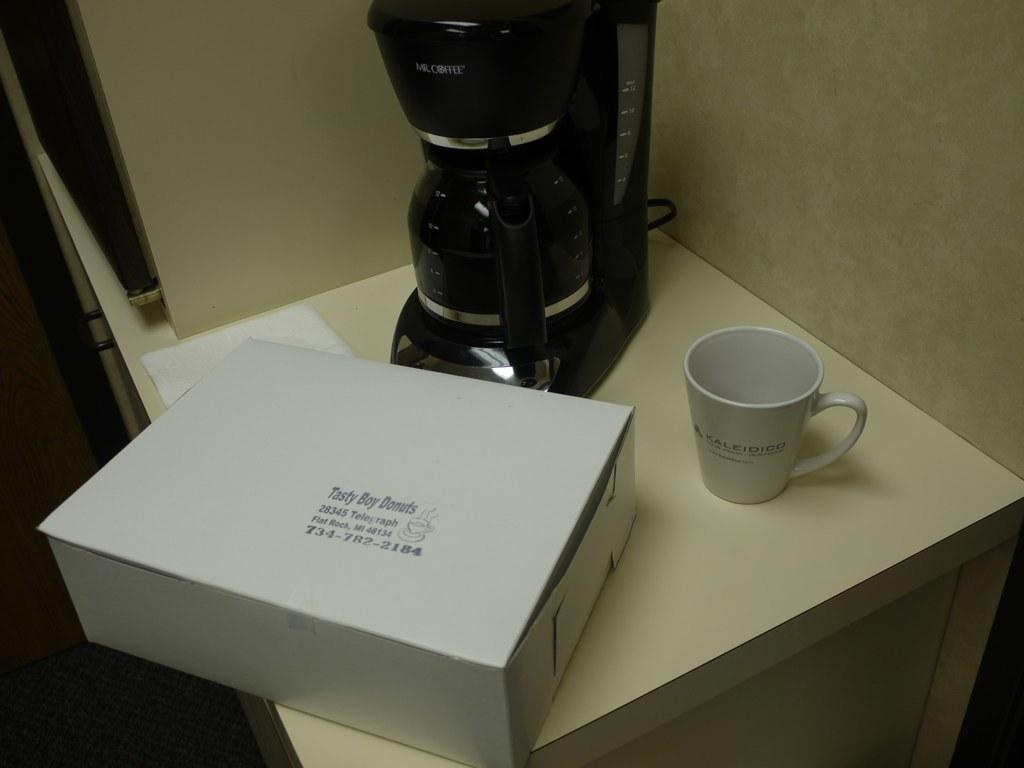<image>
Render a clear and concise summary of the photo. white countertop with a coffeemaker, coffee cup and box of tasty boy donuts on it 